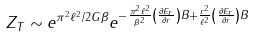<formula> <loc_0><loc_0><loc_500><loc_500>Z _ { T } \sim e ^ { \pi ^ { 2 } \ell ^ { 2 } / 2 G \beta } e ^ { - \frac { \pi ^ { 2 } \ell ^ { 2 } } { \beta ^ { 2 } } \left ( \frac { \partial E _ { r } } { \partial r } \right ) B + \frac { r ^ { 2 } } { \ell ^ { 2 } } \left ( \frac { \partial E _ { r } } { \partial r } \right ) B }</formula> 